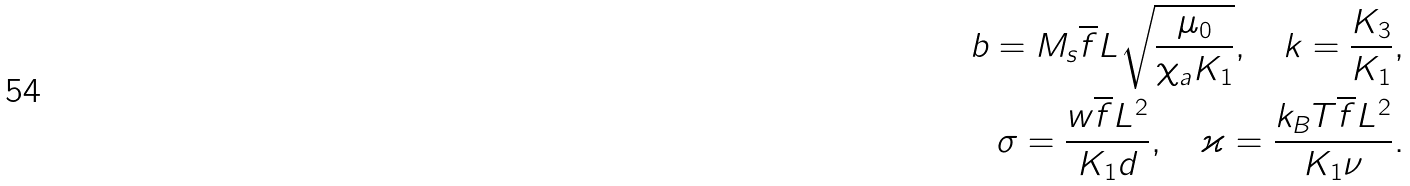<formula> <loc_0><loc_0><loc_500><loc_500>b = M _ { s } \overline { f } L \sqrt { \frac { \mu _ { 0 } } { \chi _ { a } K _ { 1 } } } , \quad k = \frac { K _ { 3 } } { K _ { 1 } } , \\ \sigma = \frac { w \overline { f } L ^ { 2 } } { K _ { 1 } d } , \quad \varkappa = \frac { k _ { B } T \overline { f } L ^ { 2 } } { K _ { 1 } \nu } .</formula> 